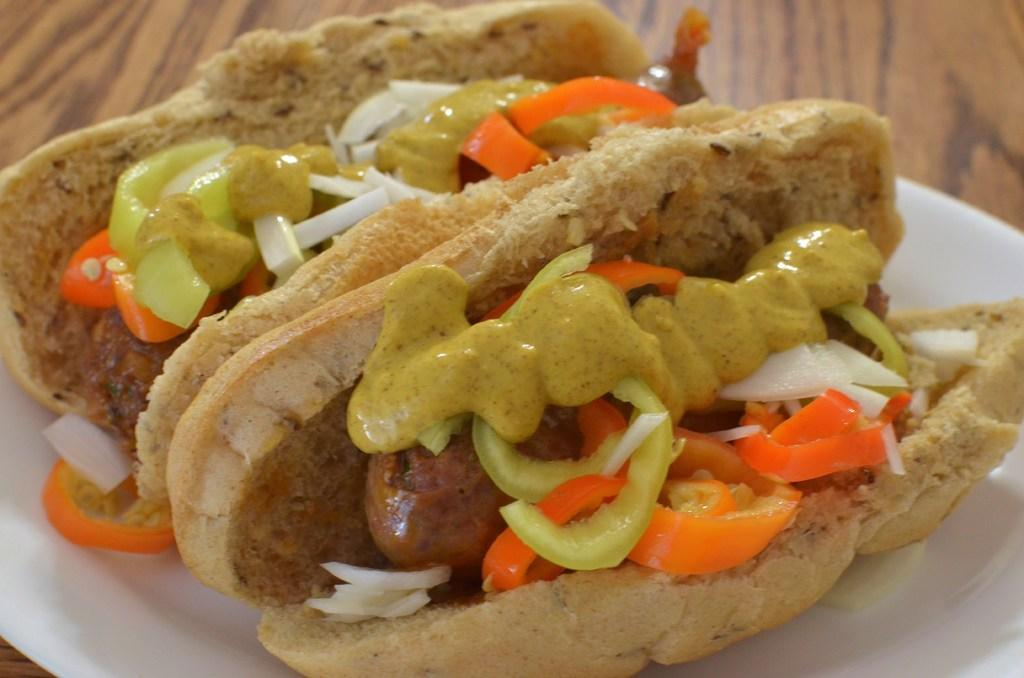What is the main object in the image? There is a wooden plank in the image. What is placed on the wooden plank? There is a plate on the wooden plank. What food items are on the plate? The plate contains two breads and a vegetable salad. Is there any condiment on the plate? Yes, there is sauce on the plate. Where is the tub located in the image? There is no tub present in the image. Can you see a crow in the image? No, there is no crow in the image. 